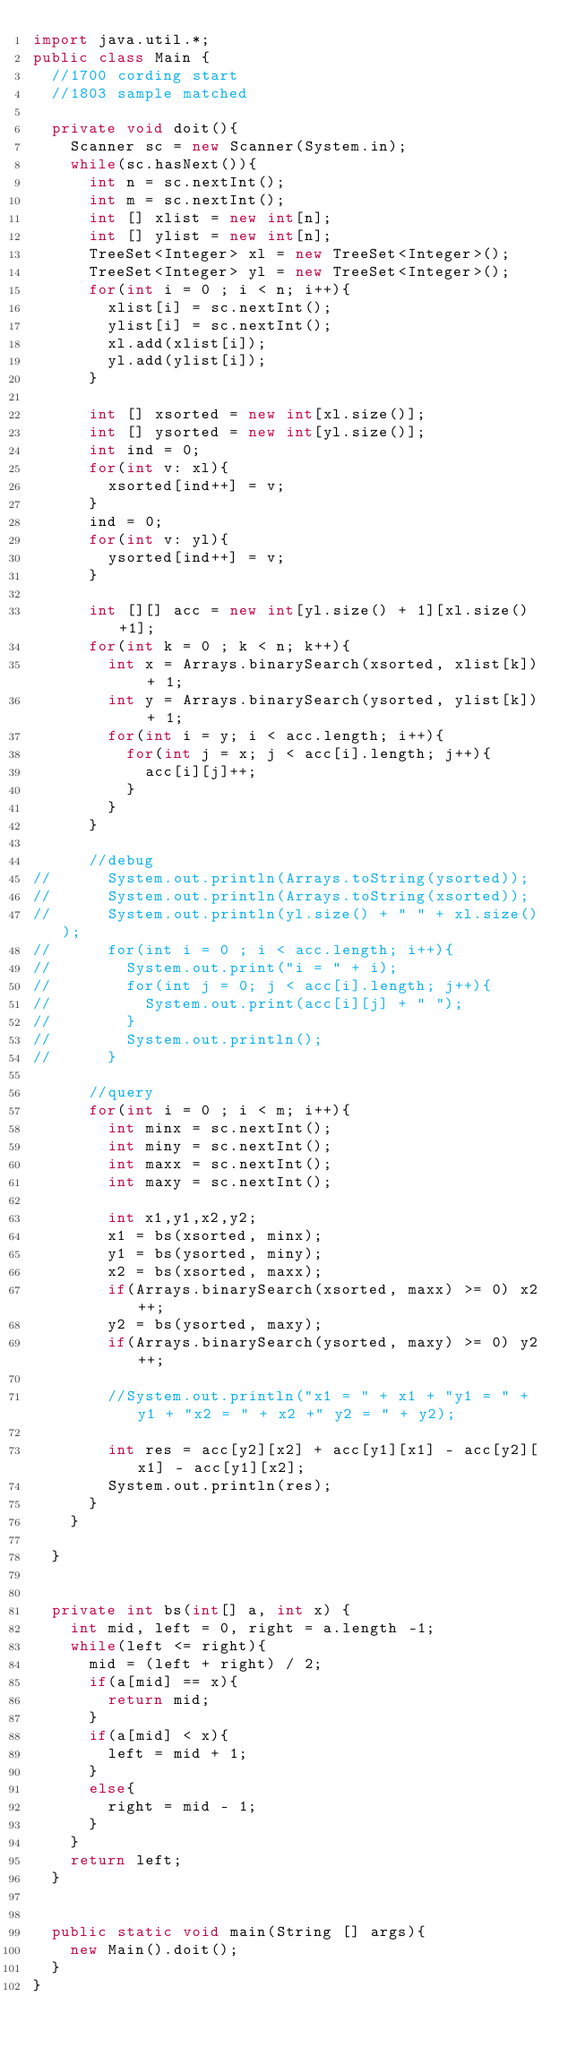<code> <loc_0><loc_0><loc_500><loc_500><_Java_>import java.util.*;
public class Main {
	//1700 cording start
	//1803 sample matched
	
	private void doit(){
		Scanner sc = new Scanner(System.in);
		while(sc.hasNext()){
			int n = sc.nextInt();
			int m = sc.nextInt();
			int [] xlist = new int[n];
			int [] ylist = new int[n];
			TreeSet<Integer> xl = new TreeSet<Integer>();
			TreeSet<Integer> yl = new TreeSet<Integer>();
			for(int i = 0 ; i < n; i++){
				xlist[i] = sc.nextInt();
				ylist[i] = sc.nextInt();
				xl.add(xlist[i]);
				yl.add(ylist[i]);
			}
			
			int [] xsorted = new int[xl.size()];
			int [] ysorted = new int[yl.size()];
			int ind = 0;
			for(int v: xl){
				xsorted[ind++] = v;
			}
			ind = 0;
			for(int v: yl){
				ysorted[ind++] = v;
			}
			
			int [][] acc = new int[yl.size() + 1][xl.size()+1];
			for(int k = 0 ; k < n; k++){
				int x = Arrays.binarySearch(xsorted, xlist[k]) + 1;
				int y = Arrays.binarySearch(ysorted, ylist[k]) + 1;
				for(int i = y; i < acc.length; i++){
					for(int j = x; j < acc[i].length; j++){
						acc[i][j]++;
					}
				}
			}
			
			//debug
//			System.out.println(Arrays.toString(ysorted));
//			System.out.println(Arrays.toString(xsorted));
//			System.out.println(yl.size() + " " + xl.size());
//			for(int i = 0 ; i < acc.length; i++){
//				System.out.print("i = " + i);
//				for(int j = 0; j < acc[i].length; j++){
//					System.out.print(acc[i][j] + " ");
//				}
//				System.out.println();
//			}
			
			//query
			for(int i = 0 ; i < m; i++){
				int minx = sc.nextInt();
				int miny = sc.nextInt();
				int maxx = sc.nextInt();
				int maxy = sc.nextInt();
				
				int x1,y1,x2,y2;
				x1 = bs(xsorted, minx);
				y1 = bs(ysorted, miny);
				x2 = bs(xsorted, maxx);
				if(Arrays.binarySearch(xsorted, maxx) >= 0) x2++;
				y2 = bs(ysorted, maxy);
				if(Arrays.binarySearch(ysorted, maxy) >= 0) y2++;
				
				//System.out.println("x1 = " + x1 + "y1 = " + y1 + "x2 = " + x2 +" y2 = " + y2);
				
				int res = acc[y2][x2] + acc[y1][x1] - acc[y2][x1] - acc[y1][x2];
				System.out.println(res);
			}
		}
		
	}


	private int bs(int[] a, int x) {
		int mid, left = 0, right = a.length -1;
		while(left <= right){
			mid = (left + right) / 2;
			if(a[mid] == x){
				return mid;
			}
			if(a[mid] < x){
				left = mid + 1;
			}
			else{
				right = mid - 1;
			}
		}
		return left;
	}


	public static void main(String [] args){
		new Main().doit();
	}
}</code> 